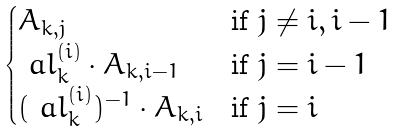<formula> <loc_0><loc_0><loc_500><loc_500>\begin{cases} A _ { k , j } & \text {if $j\ne i,i-1$} \\ \ a l ^ { ( i ) } _ { k } \cdot A _ { k , i - 1 } & \text {if $j=i-1$} \\ ( { \ a l ^ { ( i ) } _ { k } } ) ^ { - 1 } \cdot A _ { k , i } & \text {if $j=i$} \end{cases}</formula> 